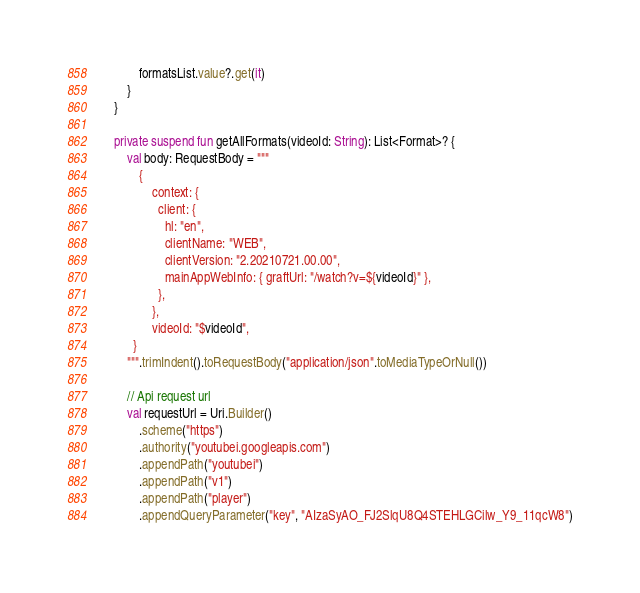Convert code to text. <code><loc_0><loc_0><loc_500><loc_500><_Kotlin_>            formatsList.value?.get(it)
        }
    }

    private suspend fun getAllFormats(videoId: String): List<Format>? {
        val body: RequestBody = """
            {
                context: {
                  client: {
                    hl: "en",
                    clientName: "WEB",
                    clientVersion: "2.20210721.00.00",
                    mainAppWebInfo: { graftUrl: "/watch?v=${videoId}" },
                  },
                },
                videoId: "$videoId",
          }
        """.trimIndent().toRequestBody("application/json".toMediaTypeOrNull())

        // Api request url
        val requestUrl = Uri.Builder()
            .scheme("https")
            .authority("youtubei.googleapis.com")
            .appendPath("youtubei")
            .appendPath("v1")
            .appendPath("player")
            .appendQueryParameter("key", "AIzaSyAO_FJ2SlqU8Q4STEHLGCilw_Y9_11qcW8")</code> 